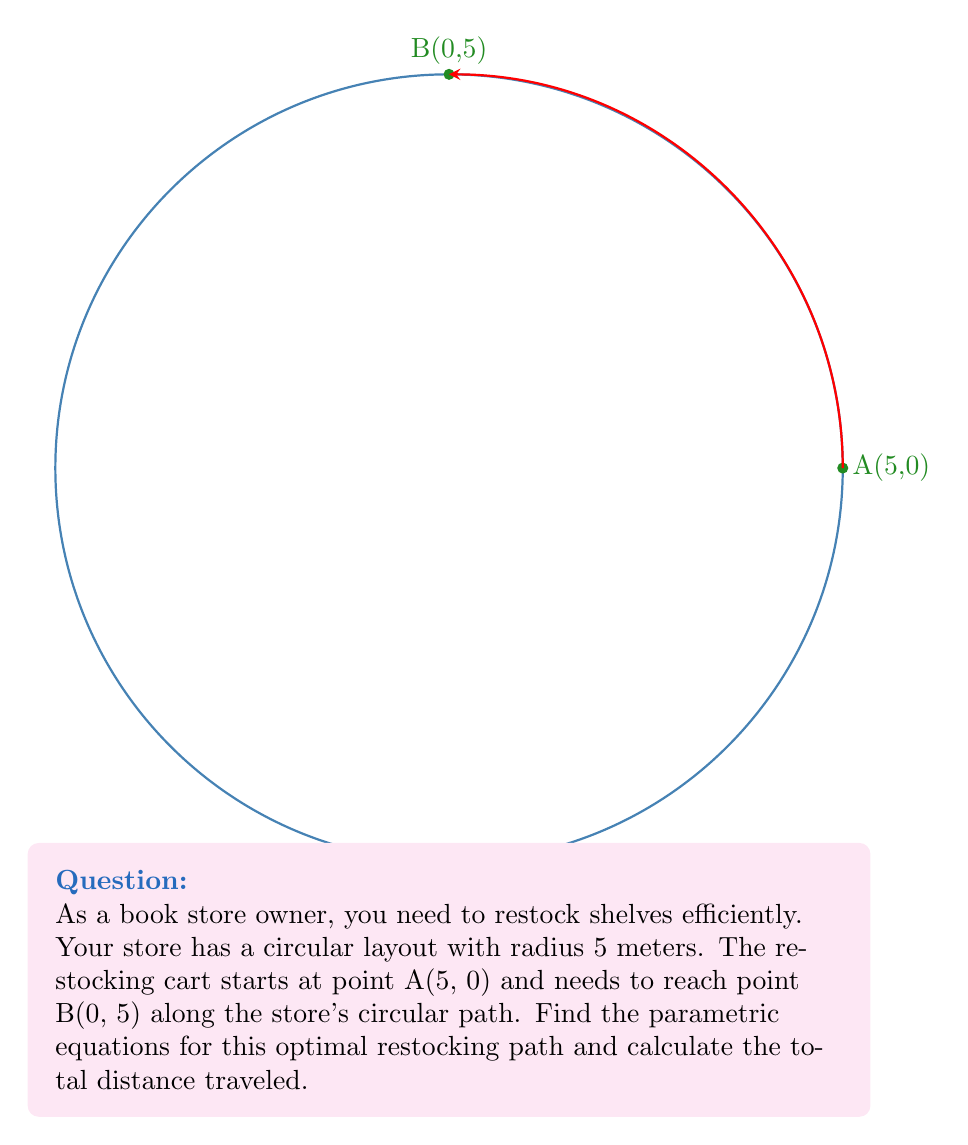Give your solution to this math problem. Let's approach this step-by-step:

1) The parametric equations for a circle with radius 5 are:
   $$x = 5\cos(t)$$
   $$y = 5\sin(t)$$
   where $0 \leq t \leq 2\pi$

2) Point A(5, 0) corresponds to $t = 0$, and point B(0, 5) corresponds to $t = \frac{\pi}{2}$

3) Therefore, the parametric equations for the path from A to B are:
   $$x = 5\cos(t)$$
   $$y = 5\sin(t)$$
   where $0 \leq t \leq \frac{\pi}{2}$

4) To calculate the distance traveled, we need to find the arc length. The formula for arc length is:
   $$s = r\theta$$
   where $r$ is the radius and $\theta$ is the central angle in radians

5) We know $r = 5$ and $\theta = \frac{\pi}{2}$

6) Plugging these values in:
   $$s = 5 \cdot \frac{\pi}{2} = \frac{5\pi}{2}$$

Therefore, the total distance traveled is $\frac{5\pi}{2}$ meters.
Answer: Parametric equations: $x = 5\cos(t)$, $y = 5\sin(t)$ for $0 \leq t \leq \frac{\pi}{2}$; Distance: $\frac{5\pi}{2}$ meters 